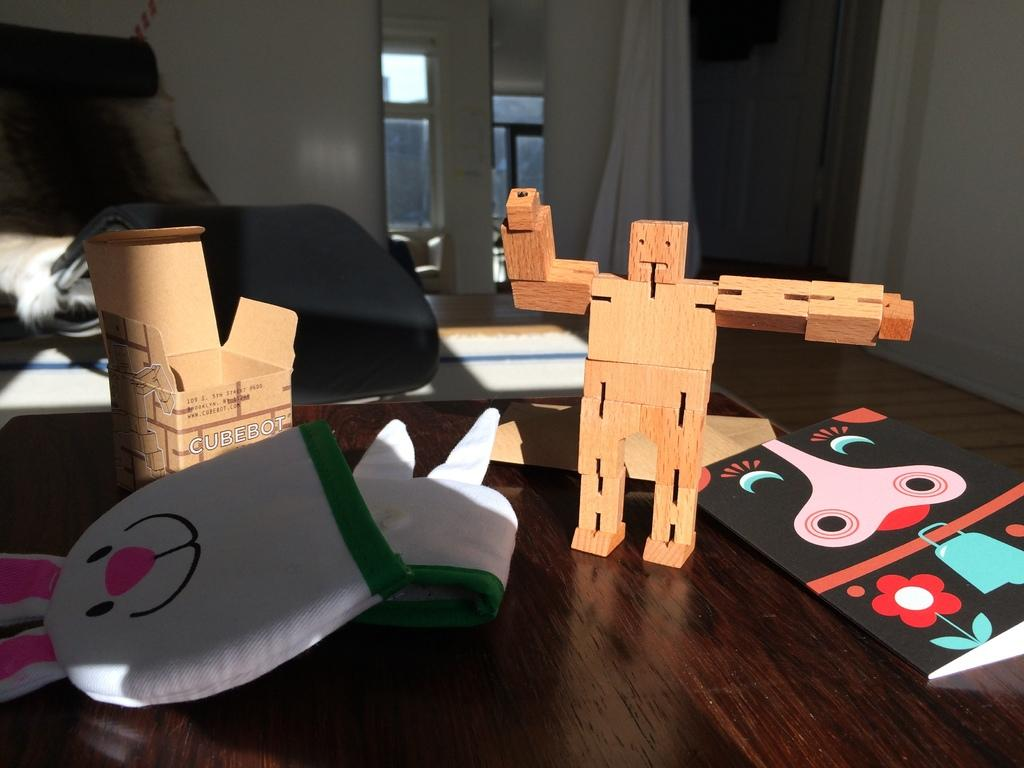<image>
Offer a succinct explanation of the picture presented. A box has "CUBEBOT" printed on the front. 